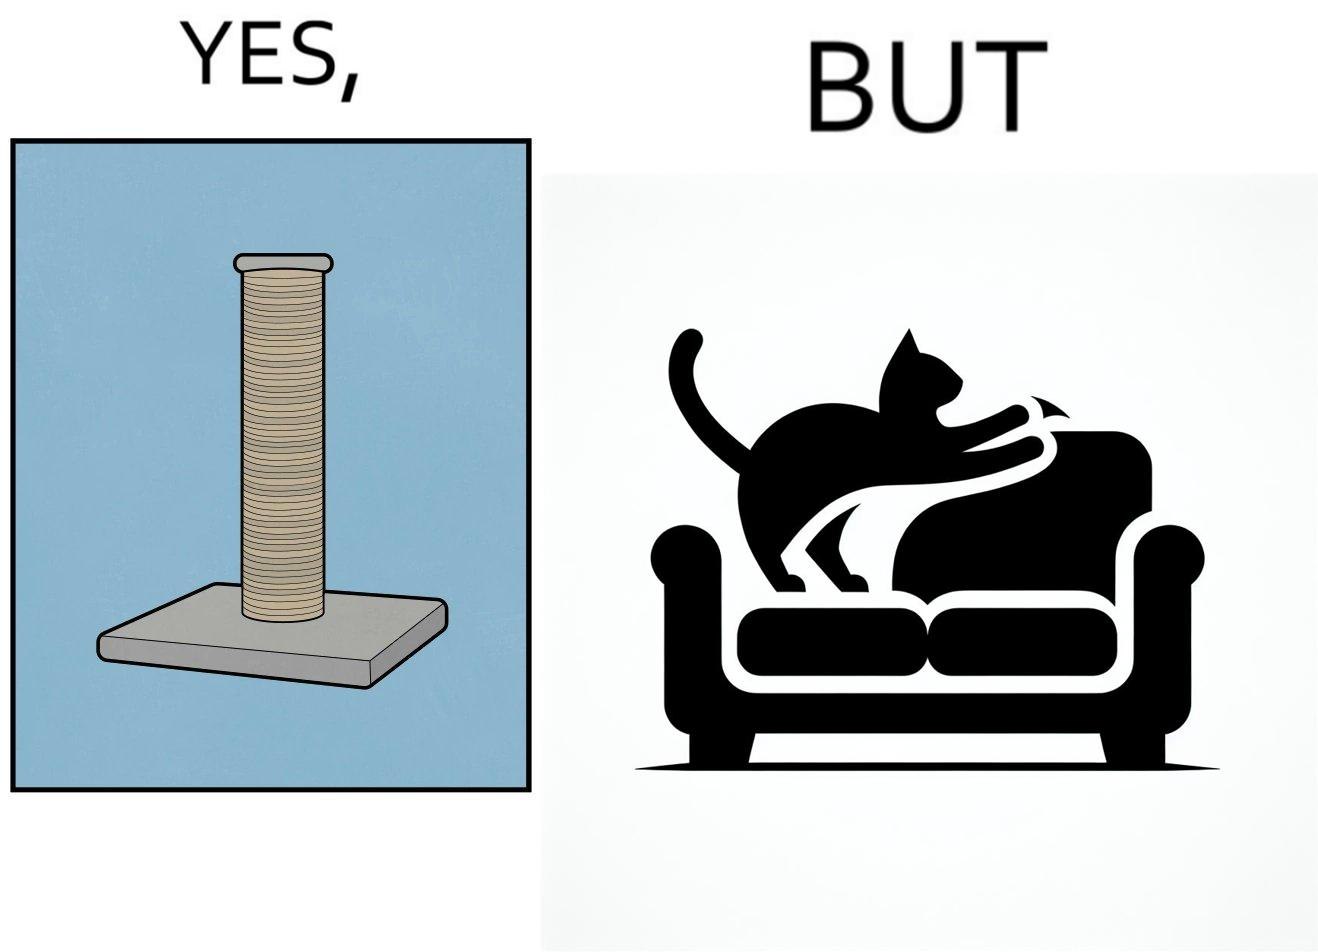What makes this image funny or satirical? The image is ironic, because in the first image a toy, purposed for the cat to play with is shown but in the second image the cat is comfortably enjoying  to play on the sides of sofa 